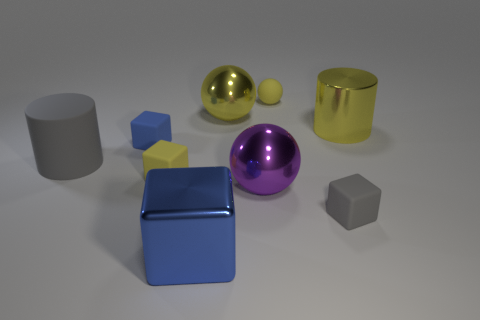Subtract all yellow balls. How many balls are left? 1 Add 1 gray rubber cylinders. How many objects exist? 10 Subtract all purple spheres. How many spheres are left? 2 Subtract all cylinders. How many objects are left? 7 Subtract 1 spheres. How many spheres are left? 2 Subtract all red balls. Subtract all brown cylinders. How many balls are left? 3 Subtract all yellow cylinders. How many purple cubes are left? 0 Subtract all small yellow blocks. Subtract all tiny shiny things. How many objects are left? 8 Add 3 big metal balls. How many big metal balls are left? 5 Add 2 tiny gray shiny objects. How many tiny gray shiny objects exist? 2 